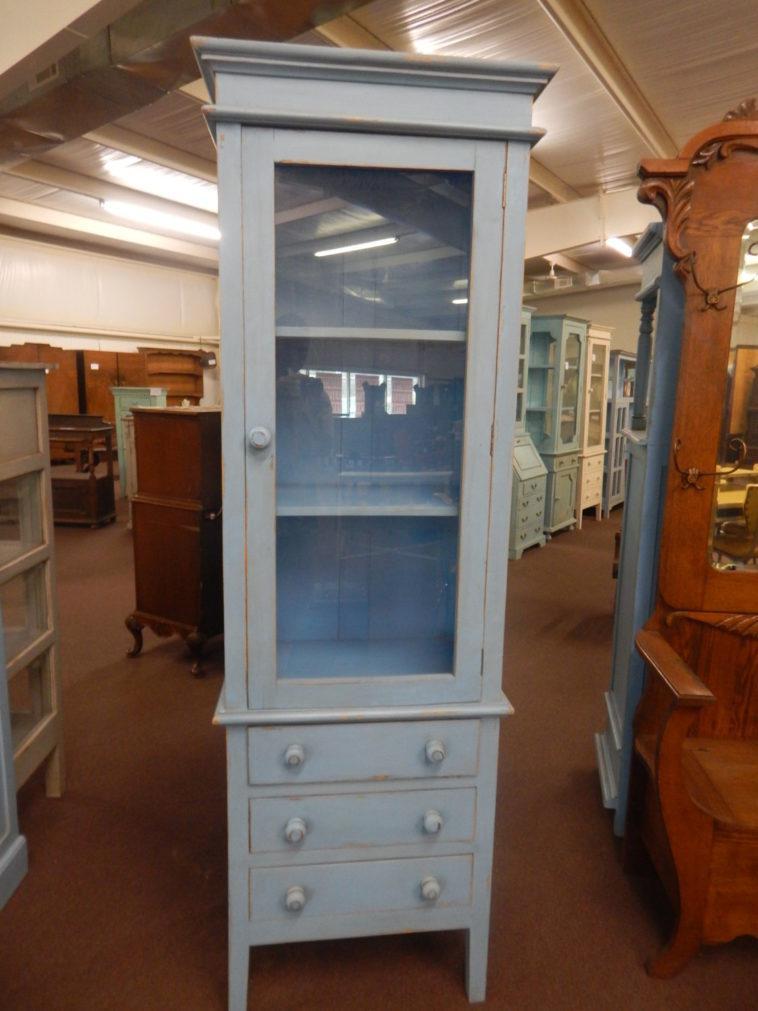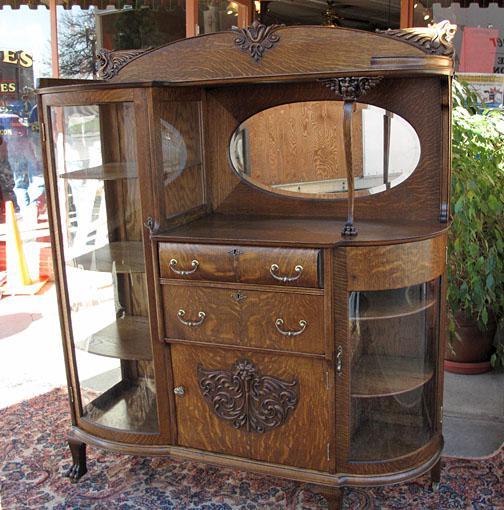The first image is the image on the left, the second image is the image on the right. Examine the images to the left and right. Is the description "At least one of the images contains an object inside a hutch." accurate? Answer yes or no. No. The first image is the image on the left, the second image is the image on the right. Evaluate the accuracy of this statement regarding the images: "An image shows a white cabinet with a decorative top element, centered glass panel, and slender legs.". Is it true? Answer yes or no. No. 